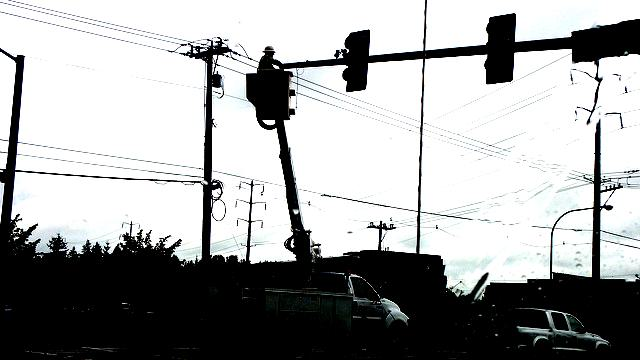What could be the purpose of the pole-like structures in the image? The prominent pole-like structures in the image are most likely utility poles. These structures are typical in both urban and rural landscapes and serve an essential purpose: they carry electrical power lines, telecommunication cables, and street lights to the surrounding area. The cluster of lines and equipment on and around these poles corroborates their role in utility distribution. 